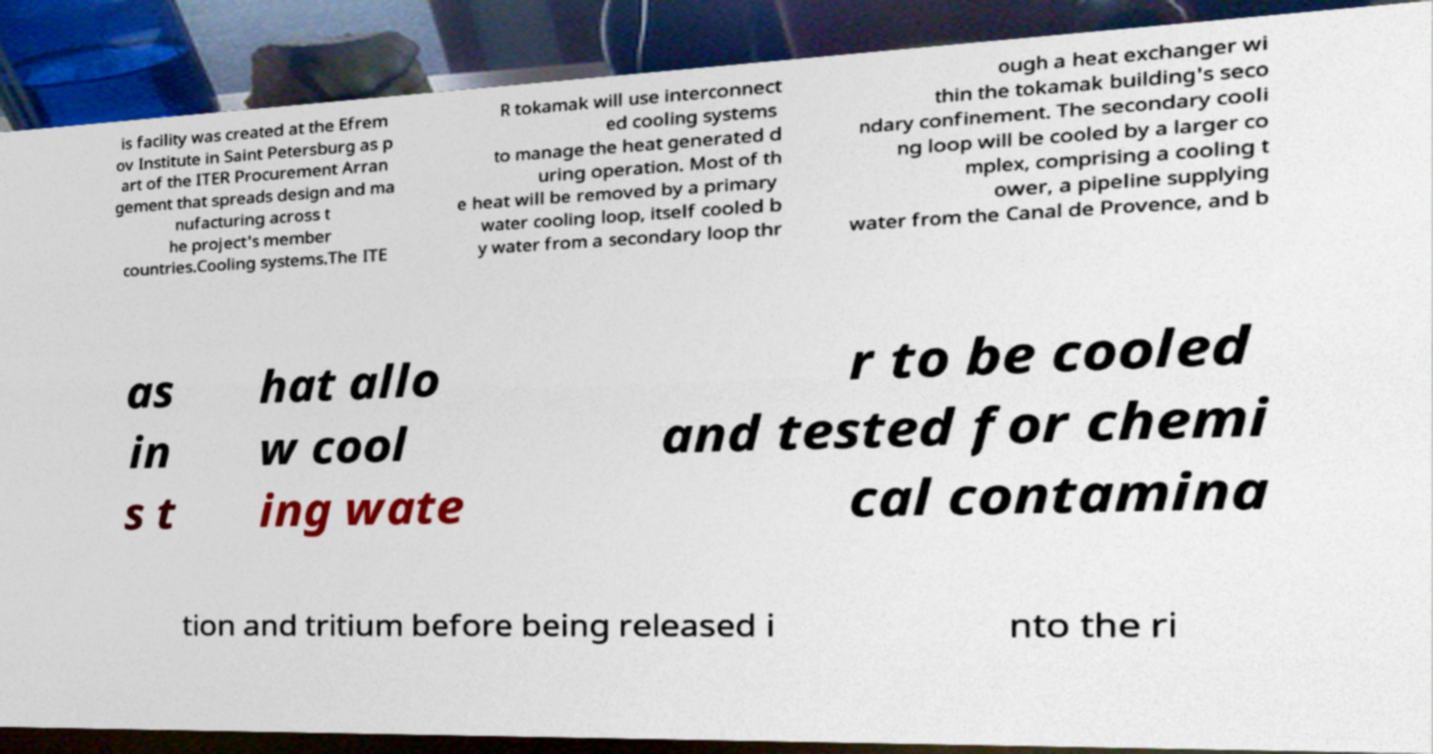I need the written content from this picture converted into text. Can you do that? is facility was created at the Efrem ov Institute in Saint Petersburg as p art of the ITER Procurement Arran gement that spreads design and ma nufacturing across t he project's member countries.Cooling systems.The ITE R tokamak will use interconnect ed cooling systems to manage the heat generated d uring operation. Most of th e heat will be removed by a primary water cooling loop, itself cooled b y water from a secondary loop thr ough a heat exchanger wi thin the tokamak building's seco ndary confinement. The secondary cooli ng loop will be cooled by a larger co mplex, comprising a cooling t ower, a pipeline supplying water from the Canal de Provence, and b as in s t hat allo w cool ing wate r to be cooled and tested for chemi cal contamina tion and tritium before being released i nto the ri 